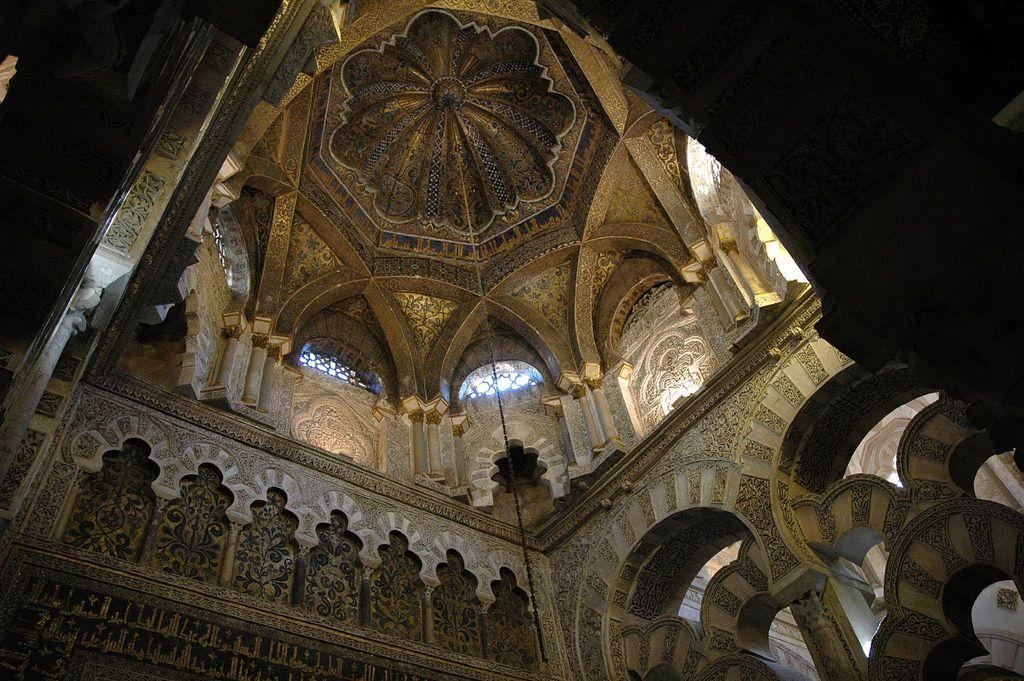What type of structure is present in the image? There is a building in the image. What can be seen on the walls of the building? The building has art on its walls. What is located at the top of the building? There is a roof at the top of the building. What type of bird is the building's manager in the image? There is no bird or manager present in the image; it only features a building with art on its walls and a roof at the top. 